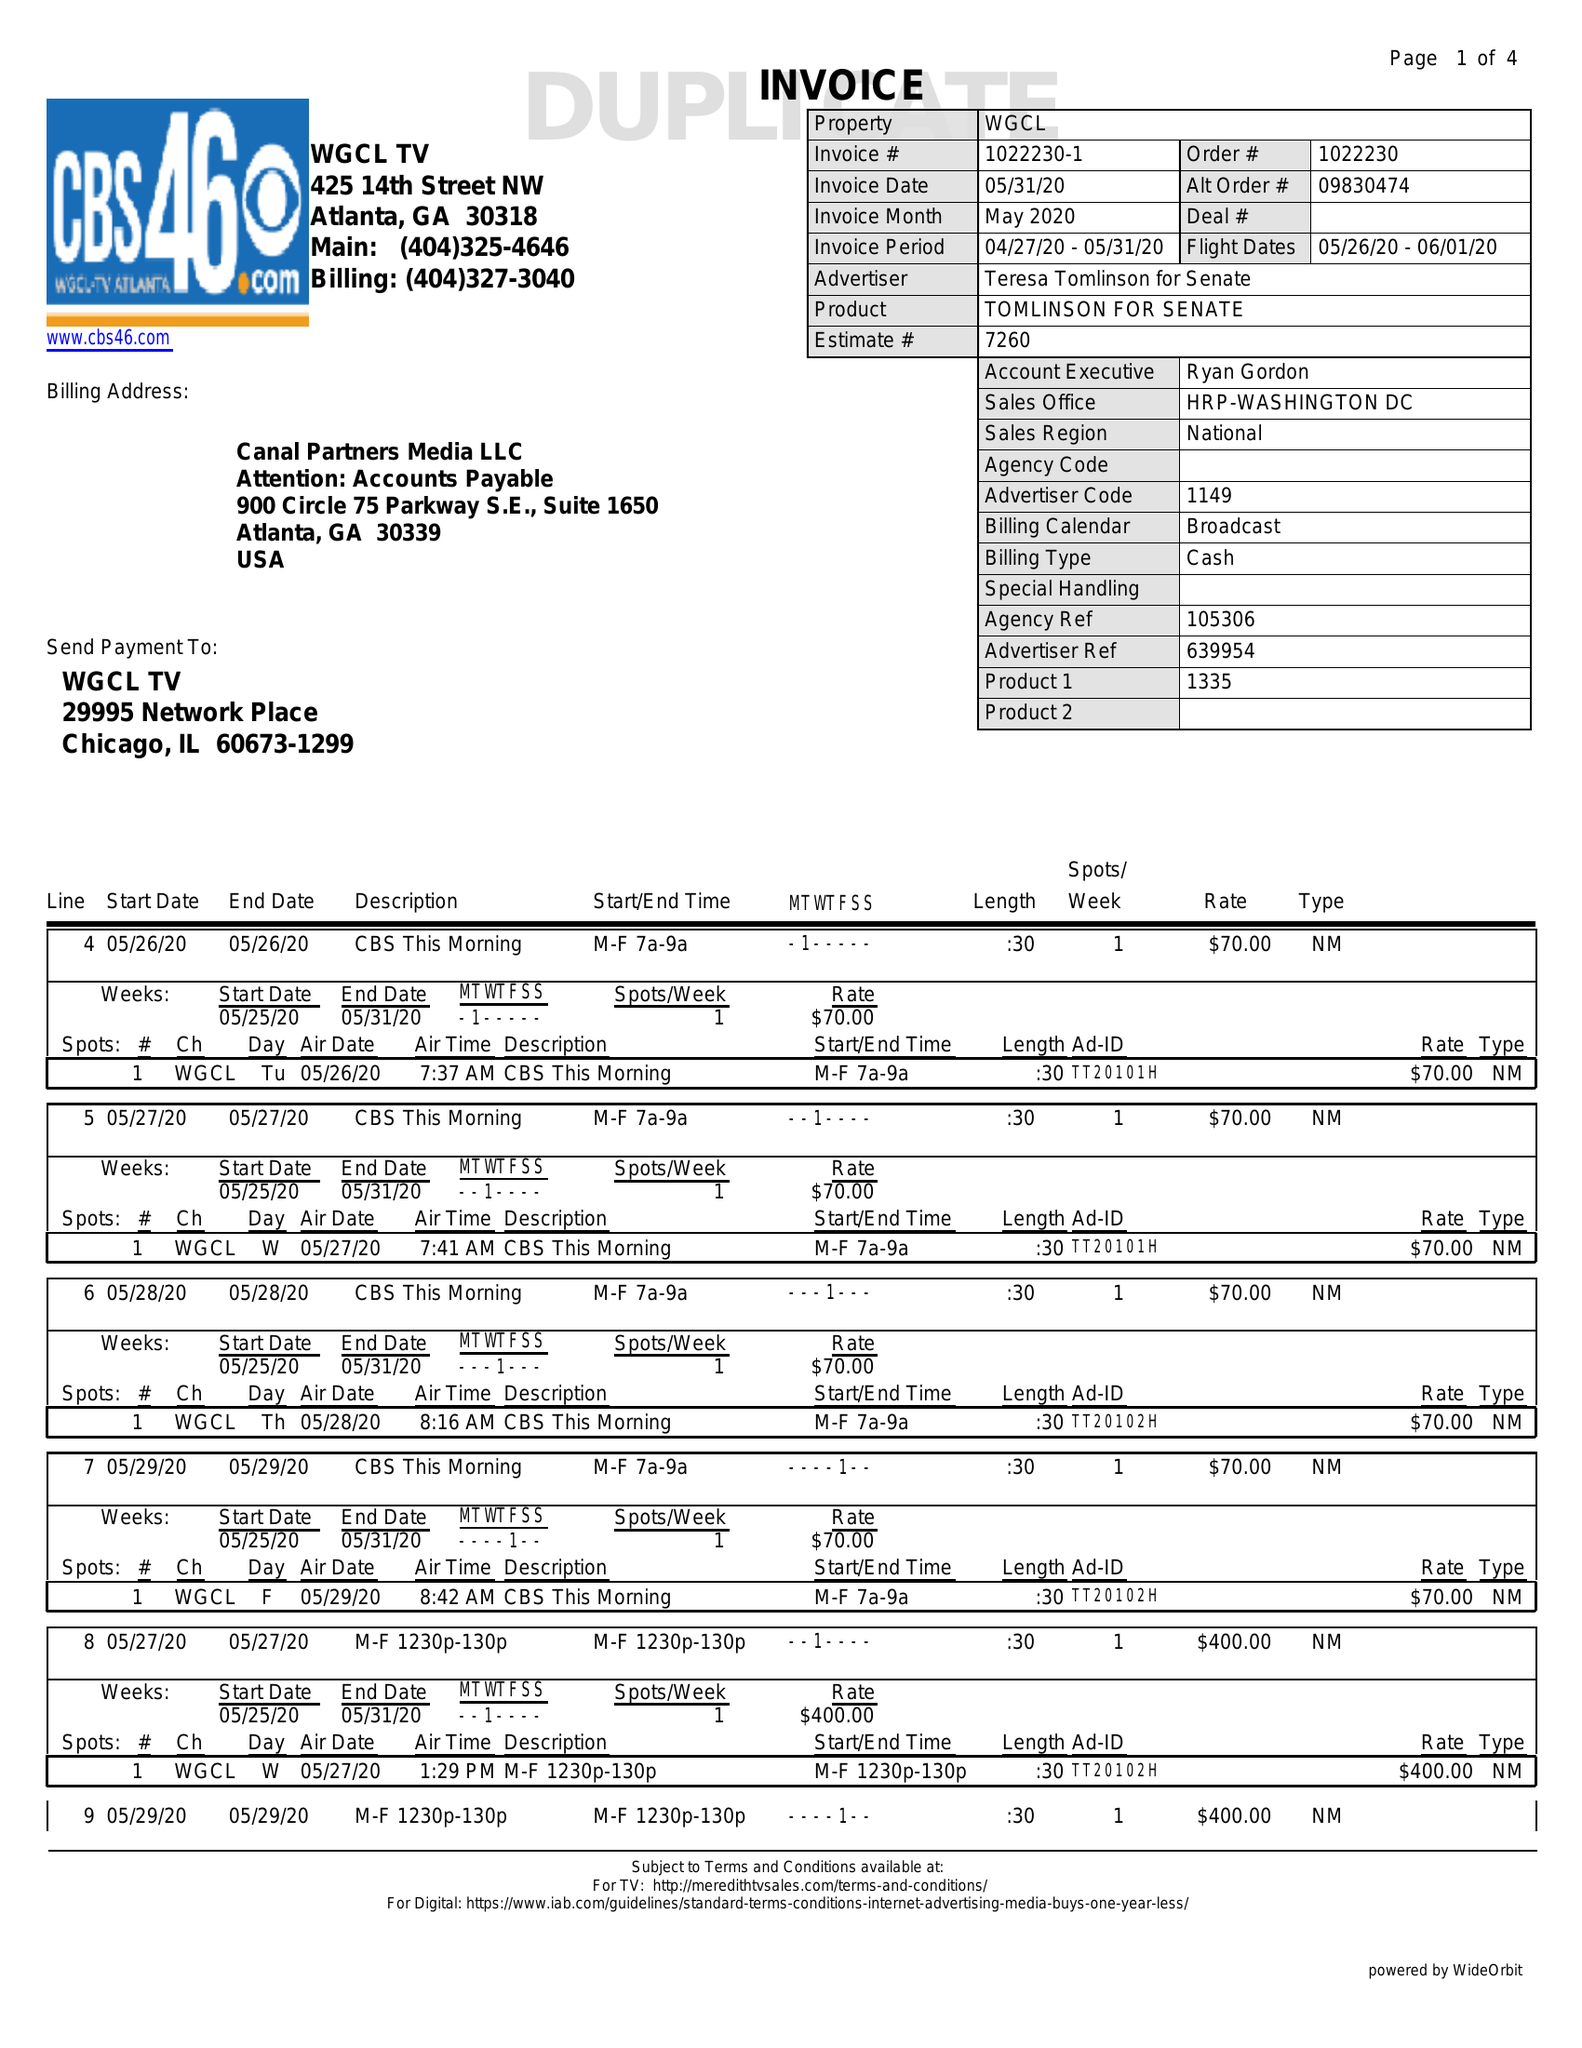What is the value for the advertiser?
Answer the question using a single word or phrase. TERESA TOMLINSON FOR SENATE 